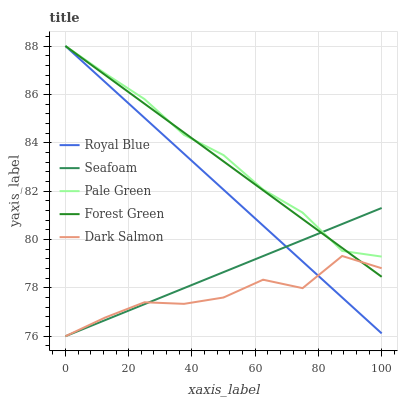Does Dark Salmon have the minimum area under the curve?
Answer yes or no. Yes. Does Pale Green have the maximum area under the curve?
Answer yes or no. Yes. Does Forest Green have the minimum area under the curve?
Answer yes or no. No. Does Forest Green have the maximum area under the curve?
Answer yes or no. No. Is Forest Green the smoothest?
Answer yes or no. Yes. Is Dark Salmon the roughest?
Answer yes or no. Yes. Is Pale Green the smoothest?
Answer yes or no. No. Is Pale Green the roughest?
Answer yes or no. No. Does Seafoam have the lowest value?
Answer yes or no. Yes. Does Forest Green have the lowest value?
Answer yes or no. No. Does Pale Green have the highest value?
Answer yes or no. Yes. Does Seafoam have the highest value?
Answer yes or no. No. Is Dark Salmon less than Pale Green?
Answer yes or no. Yes. Is Pale Green greater than Dark Salmon?
Answer yes or no. Yes. Does Seafoam intersect Pale Green?
Answer yes or no. Yes. Is Seafoam less than Pale Green?
Answer yes or no. No. Is Seafoam greater than Pale Green?
Answer yes or no. No. Does Dark Salmon intersect Pale Green?
Answer yes or no. No. 